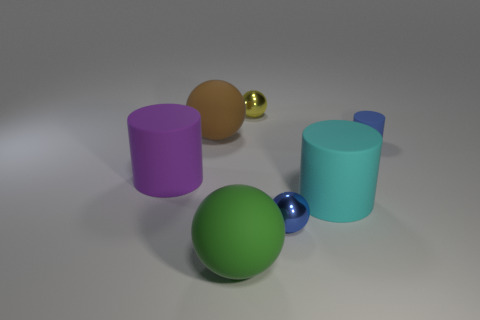The other small thing that is the same shape as the yellow thing is what color?
Ensure brevity in your answer.  Blue. What number of purple cylinders have the same material as the cyan cylinder?
Give a very brief answer. 1. There is a rubber cylinder to the left of the tiny sphere behind the brown sphere; how many small blue objects are in front of it?
Your answer should be compact. 1. Is the shape of the purple matte thing the same as the blue matte thing?
Provide a succinct answer. Yes. Are there any cyan things that have the same shape as the yellow metal object?
Ensure brevity in your answer.  No. The blue shiny thing that is the same size as the blue rubber cylinder is what shape?
Provide a succinct answer. Sphere. What is the material of the blue object that is on the right side of the shiny object in front of the sphere on the left side of the big green rubber thing?
Your answer should be compact. Rubber. Do the green ball and the yellow metallic ball have the same size?
Your response must be concise. No. What is the material of the tiny yellow sphere?
Make the answer very short. Metal. There is a sphere that is the same color as the tiny rubber cylinder; what is its material?
Provide a short and direct response. Metal. 